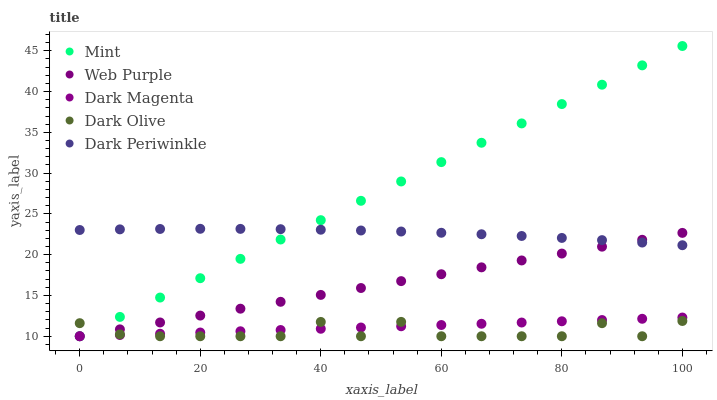Does Dark Olive have the minimum area under the curve?
Answer yes or no. Yes. Does Mint have the maximum area under the curve?
Answer yes or no. Yes. Does Mint have the minimum area under the curve?
Answer yes or no. No. Does Dark Olive have the maximum area under the curve?
Answer yes or no. No. Is Dark Magenta the smoothest?
Answer yes or no. Yes. Is Dark Olive the roughest?
Answer yes or no. Yes. Is Mint the smoothest?
Answer yes or no. No. Is Mint the roughest?
Answer yes or no. No. Does Web Purple have the lowest value?
Answer yes or no. Yes. Does Dark Periwinkle have the lowest value?
Answer yes or no. No. Does Mint have the highest value?
Answer yes or no. Yes. Does Dark Olive have the highest value?
Answer yes or no. No. Is Dark Olive less than Dark Periwinkle?
Answer yes or no. Yes. Is Dark Periwinkle greater than Dark Magenta?
Answer yes or no. Yes. Does Web Purple intersect Dark Periwinkle?
Answer yes or no. Yes. Is Web Purple less than Dark Periwinkle?
Answer yes or no. No. Is Web Purple greater than Dark Periwinkle?
Answer yes or no. No. Does Dark Olive intersect Dark Periwinkle?
Answer yes or no. No. 